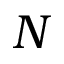Convert formula to latex. <formula><loc_0><loc_0><loc_500><loc_500>N</formula> 